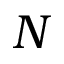Convert formula to latex. <formula><loc_0><loc_0><loc_500><loc_500>N</formula> 